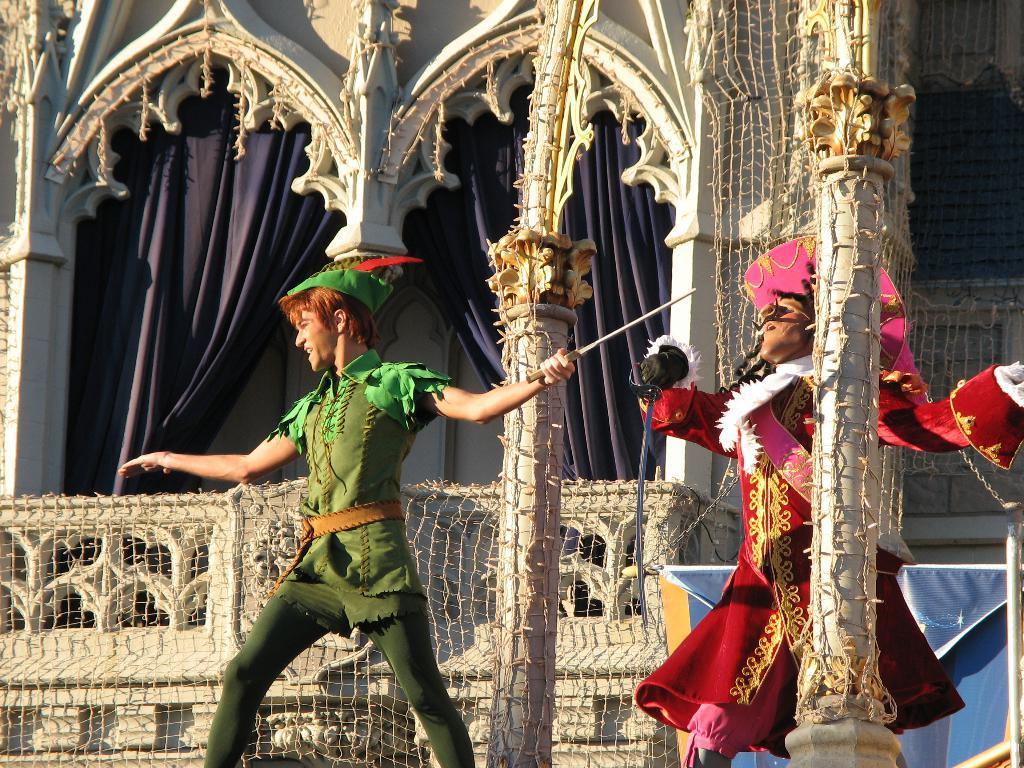Can you describe this image briefly? In this image we can see there are two people dancing and holding a knife. At the back there is a building covered with net. And there are curtains and banner. 